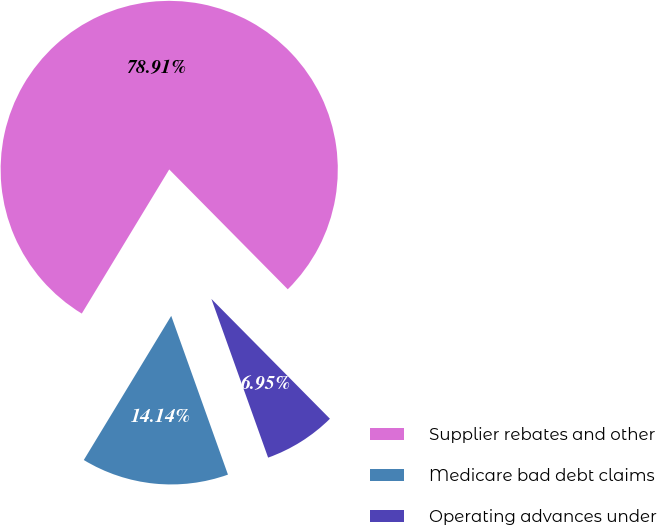<chart> <loc_0><loc_0><loc_500><loc_500><pie_chart><fcel>Supplier rebates and other<fcel>Medicare bad debt claims<fcel>Operating advances under<nl><fcel>78.91%<fcel>14.14%<fcel>6.95%<nl></chart> 